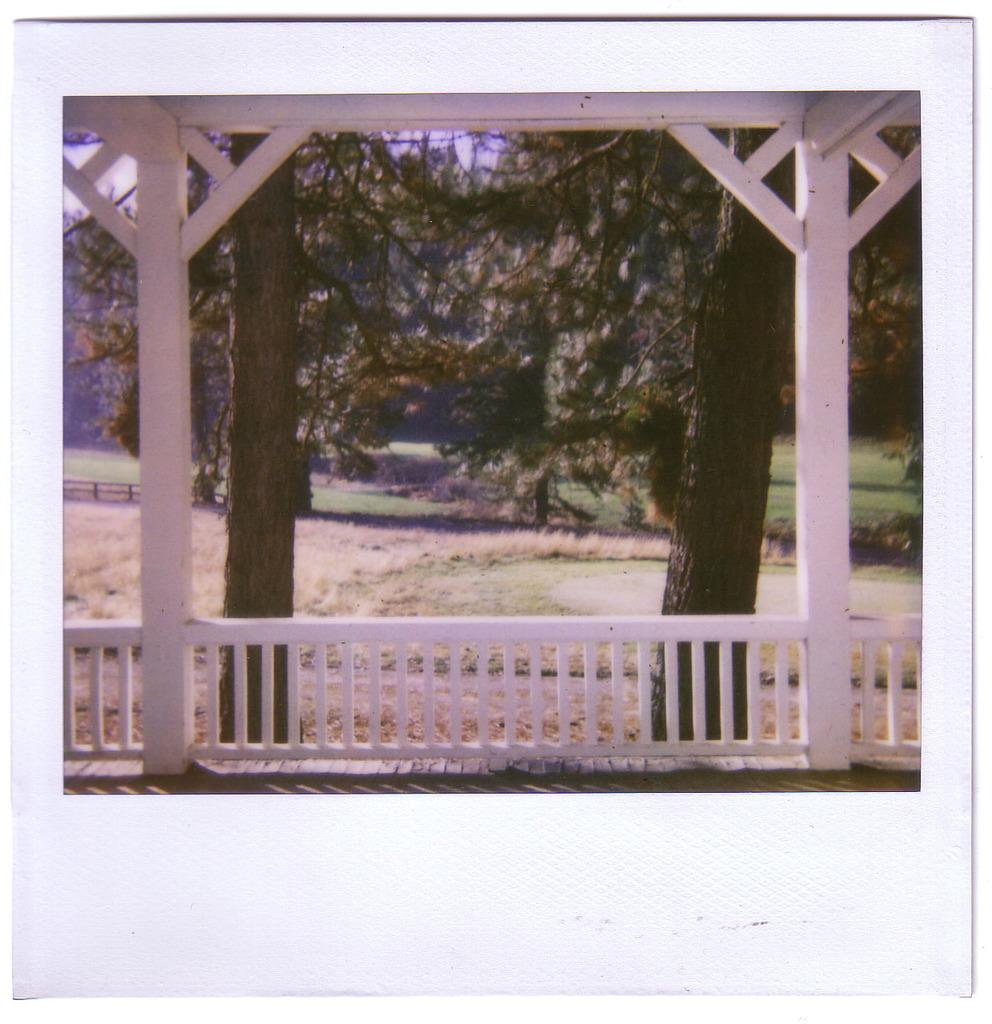What type of structure can be seen in the image? There are wooden pillars in the image, which suggests a structure of some kind. What feature is present to provide support or safety? There is a railing in the image, which is often used for support or safety. What type of natural environment is visible in the background? There are trees and a grassy land in the background of the image, indicating a natural setting. What part of the sky can be seen in the image? The sky is visible in the background of the image. What type of cork can be seen in the image? There is no cork present in the image. What type of laborer is working on the wooden pillars in the image? There is no laborer present in the image; it only shows the wooden pillars and railing. 